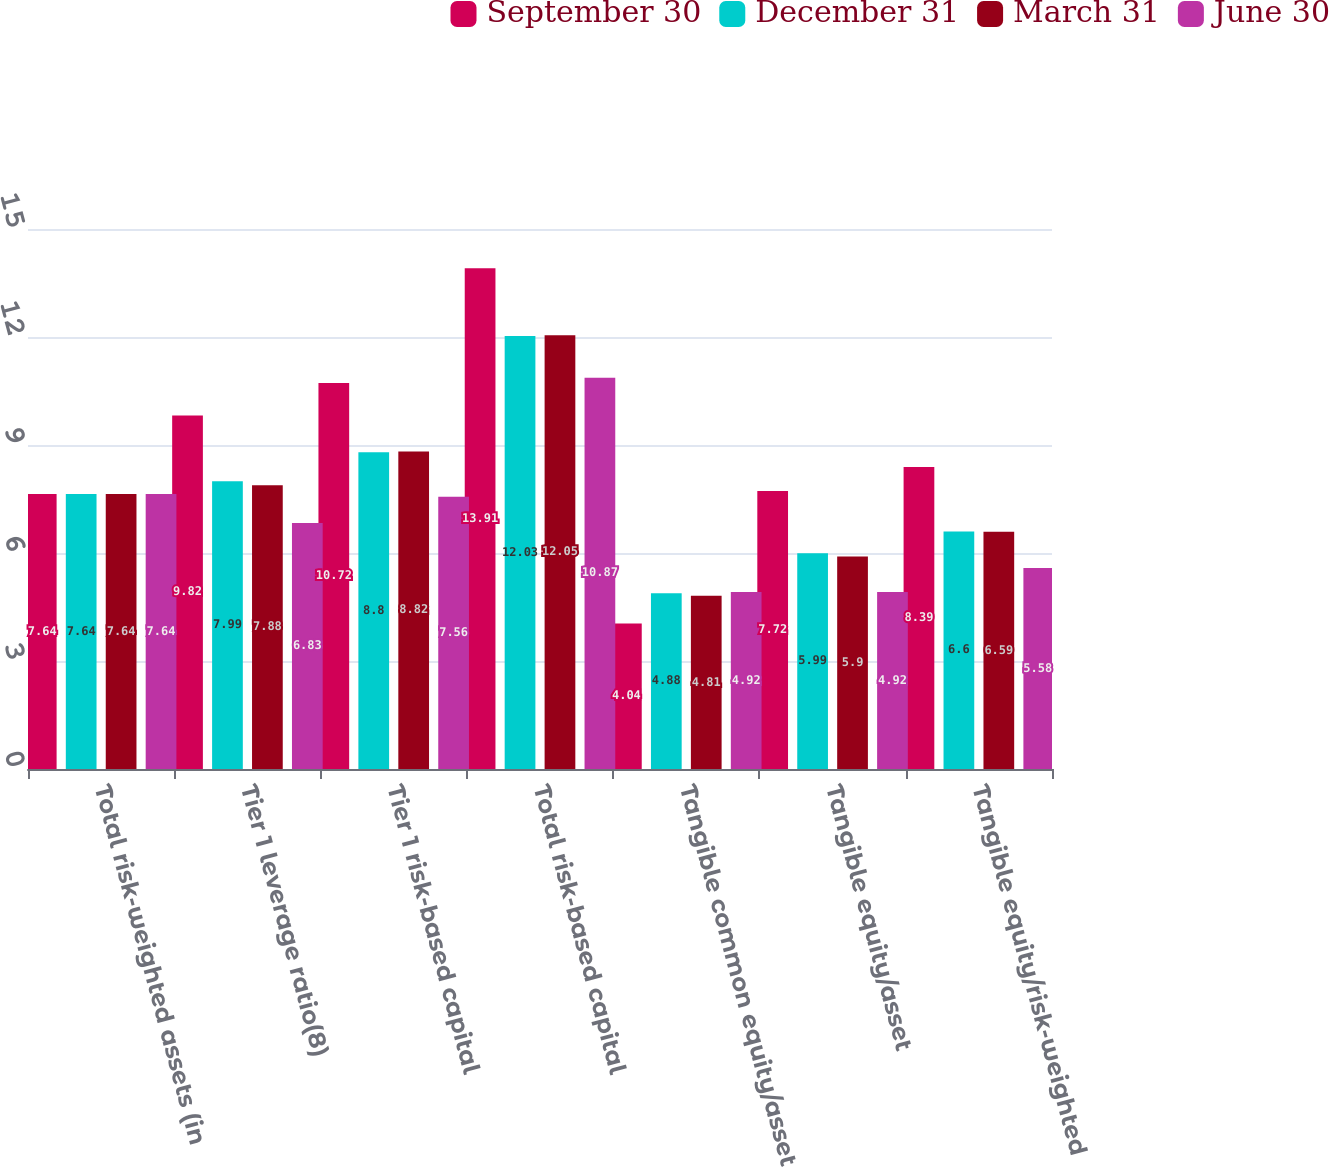Convert chart. <chart><loc_0><loc_0><loc_500><loc_500><stacked_bar_chart><ecel><fcel>Total risk-weighted assets (in<fcel>Tier 1 leverage ratio(8)<fcel>Tier 1 risk-based capital<fcel>Total risk-based capital<fcel>Tangible common equity/asset<fcel>Tangible equity/asset<fcel>Tangible equity/risk-weighted<nl><fcel>September 30<fcel>7.64<fcel>9.82<fcel>10.72<fcel>13.91<fcel>4.04<fcel>7.72<fcel>8.39<nl><fcel>December 31<fcel>7.64<fcel>7.99<fcel>8.8<fcel>12.03<fcel>4.88<fcel>5.99<fcel>6.6<nl><fcel>March 31<fcel>7.64<fcel>7.88<fcel>8.82<fcel>12.05<fcel>4.81<fcel>5.9<fcel>6.59<nl><fcel>June 30<fcel>7.64<fcel>6.83<fcel>7.56<fcel>10.87<fcel>4.92<fcel>4.92<fcel>5.58<nl></chart> 